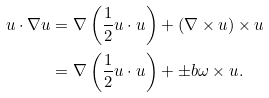<formula> <loc_0><loc_0><loc_500><loc_500>u \cdot \nabla u & = \nabla \left ( \frac { 1 } { 2 } u \cdot u \right ) + ( \nabla \times u ) \times u \\ & = \nabla \left ( \frac { 1 } { 2 } u \cdot u \right ) + \pm b \omega \times u .</formula> 